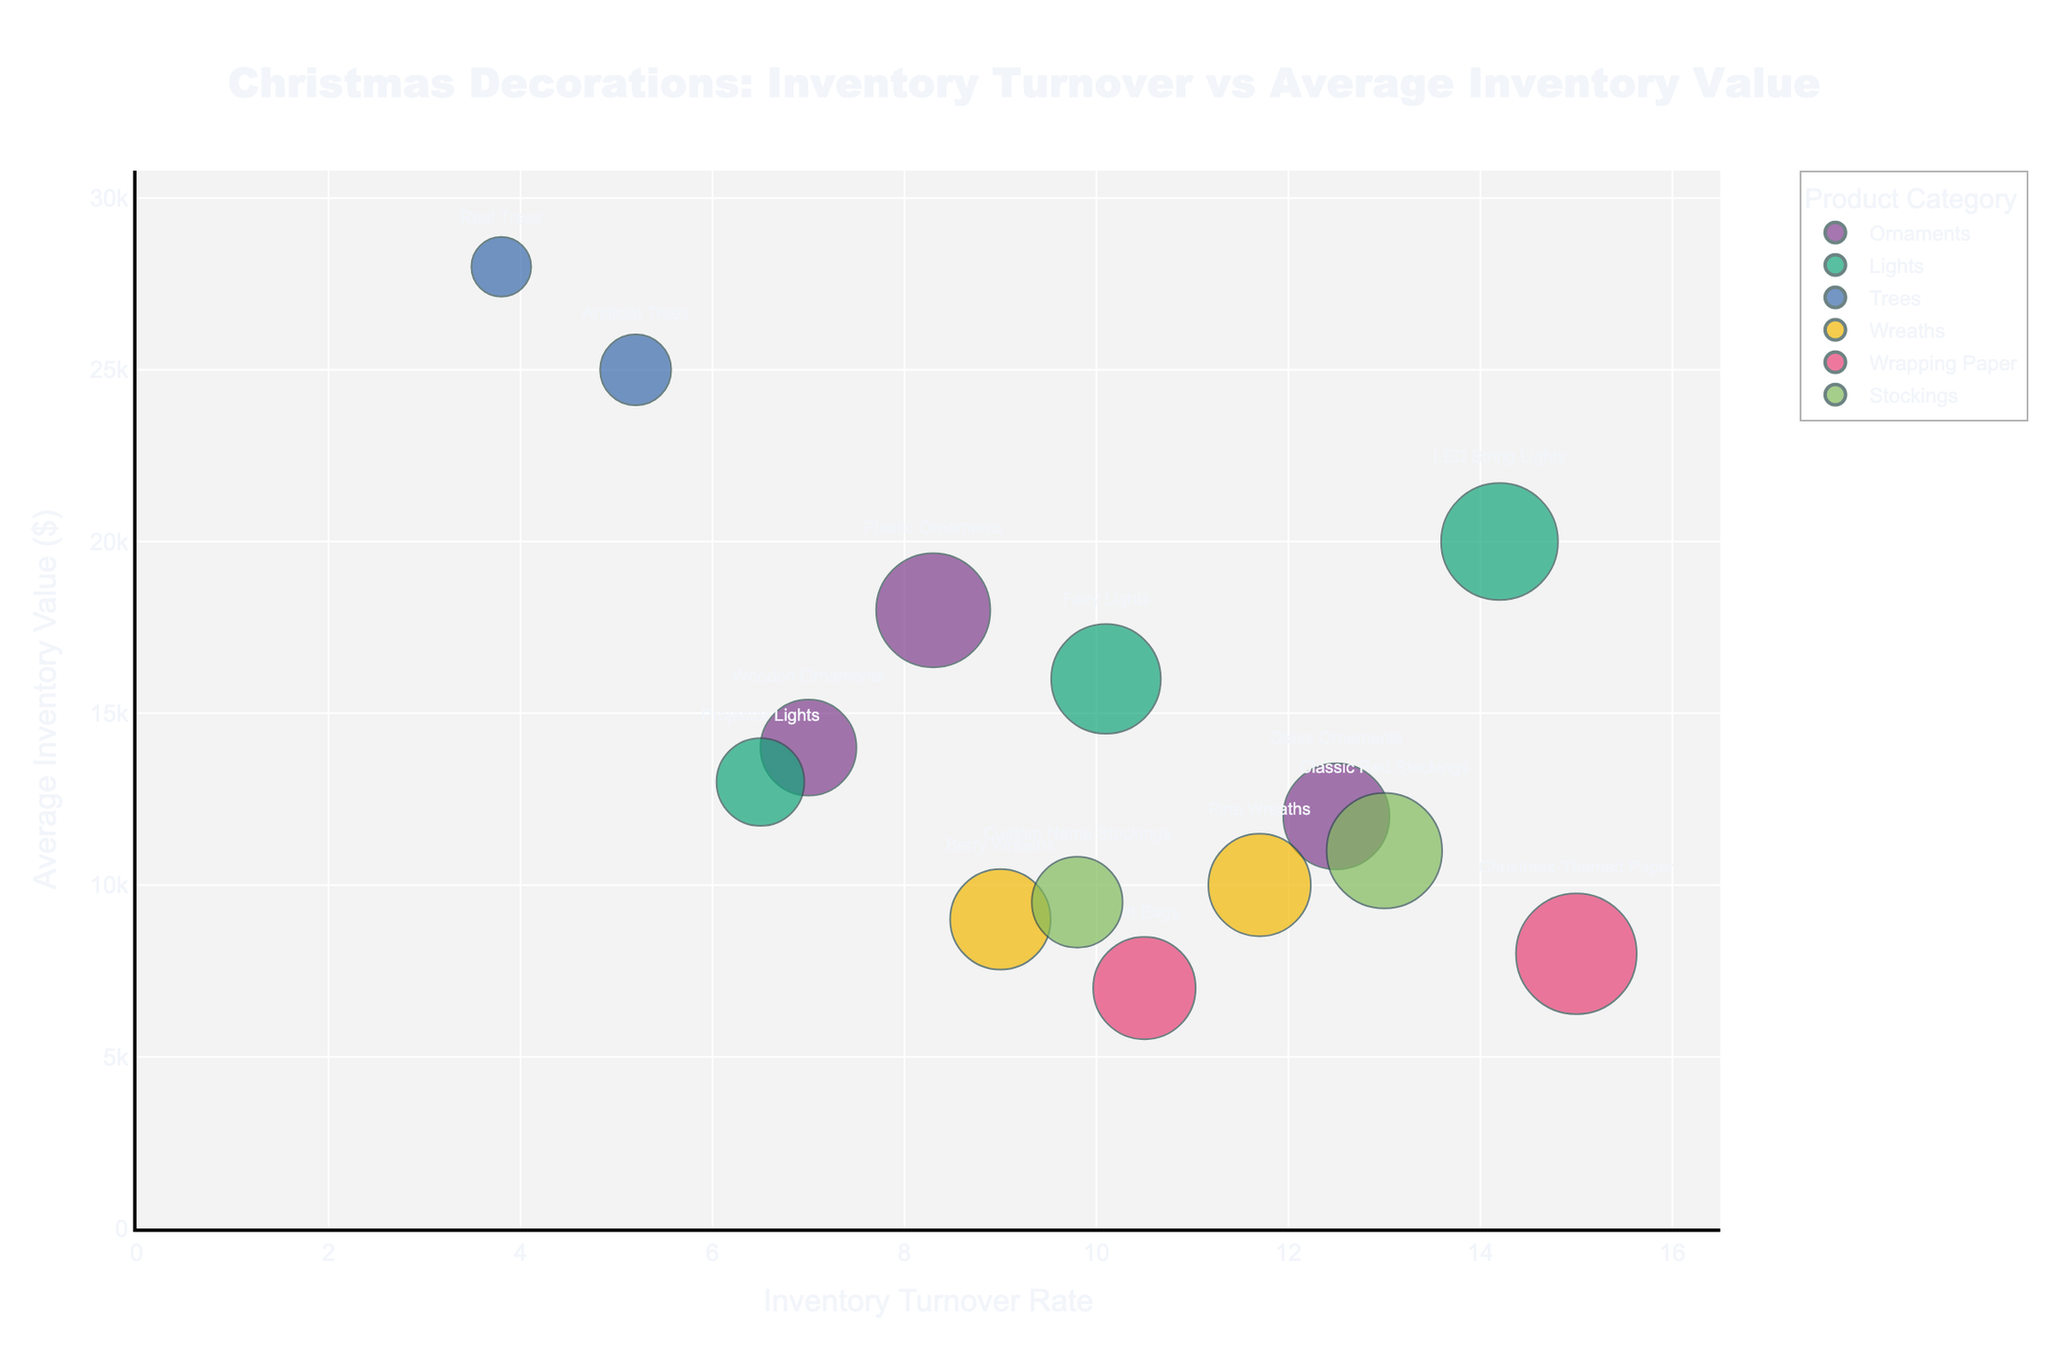How many product categories are represented in the chart? Look at the legend in the chart. Each color represents a different product category. Count the distinct categories shown.
Answer: 6 Which subcategory has the highest inventory turnover rate? Identify the bubble closest to the far right on the x-axis labeled 'Inventory Turnover Rate'. The hover information or label will indicate the subcategory.
Answer: Christmas-Themed Paper What is the average inventory value of the subcategory with the lowest units sold? First, find the bubble with the smallest size (indicating the fewest units sold). Use the hover information or label to determine its average inventory value on the y-axis.
Answer: $28,000 Which category has the highest average inventory turnover rate across its subcategories? For each category, calculate the average inventory turnover rate of its subcategories. Compare these averages to determine which is the highest.
Answer: Lights Do LED String Lights or Fairy Lights have a higher inventory turnover rate? Locate the bubbles labeled LED String Lights and Fairy Lights. Compare their positions on the x-axis, which represents the inventory turnover rate.
Answer: LED String Lights What is the total inventory turnover for the Wrapping Paper category? Sum the inventory turnover rates of the subcategories within Wrapping Paper. This involves locating Christmas-Themed Paper (15.0) and Gift Bags (10.5), then adding their turnovers.
Answer: 25.5 Which subcategory in the Wreaths category has a lower average inventory value? Identify the bubbles representing subcategories within the Wreaths category. Compare their positions on the y-axis to find which one is lower.
Answer: Berry Wreaths Which product category has the most units sold in total? Sum the units sold for each subcategory within each category. Compare the sums to find the category with the highest total units sold.
Answer: Lights Are there subcategories from different categories with the same average inventory value? Look at the y-axis and identify if any horizontal alignments exist among the bubbles, indicating the same average inventory value. Hover over these bubbles to check if they belong to different categories.
Answer: No What is the relative size of the bubble representing Real Trees compared to the bubble representing Artificial Trees? Compare the sizes of the bubbles for Real Trees and Artificial Trees visually or via hover information. Determine if one is larger, smaller, or equal in size and state the relationship.
Answer: Real Trees is smaller 